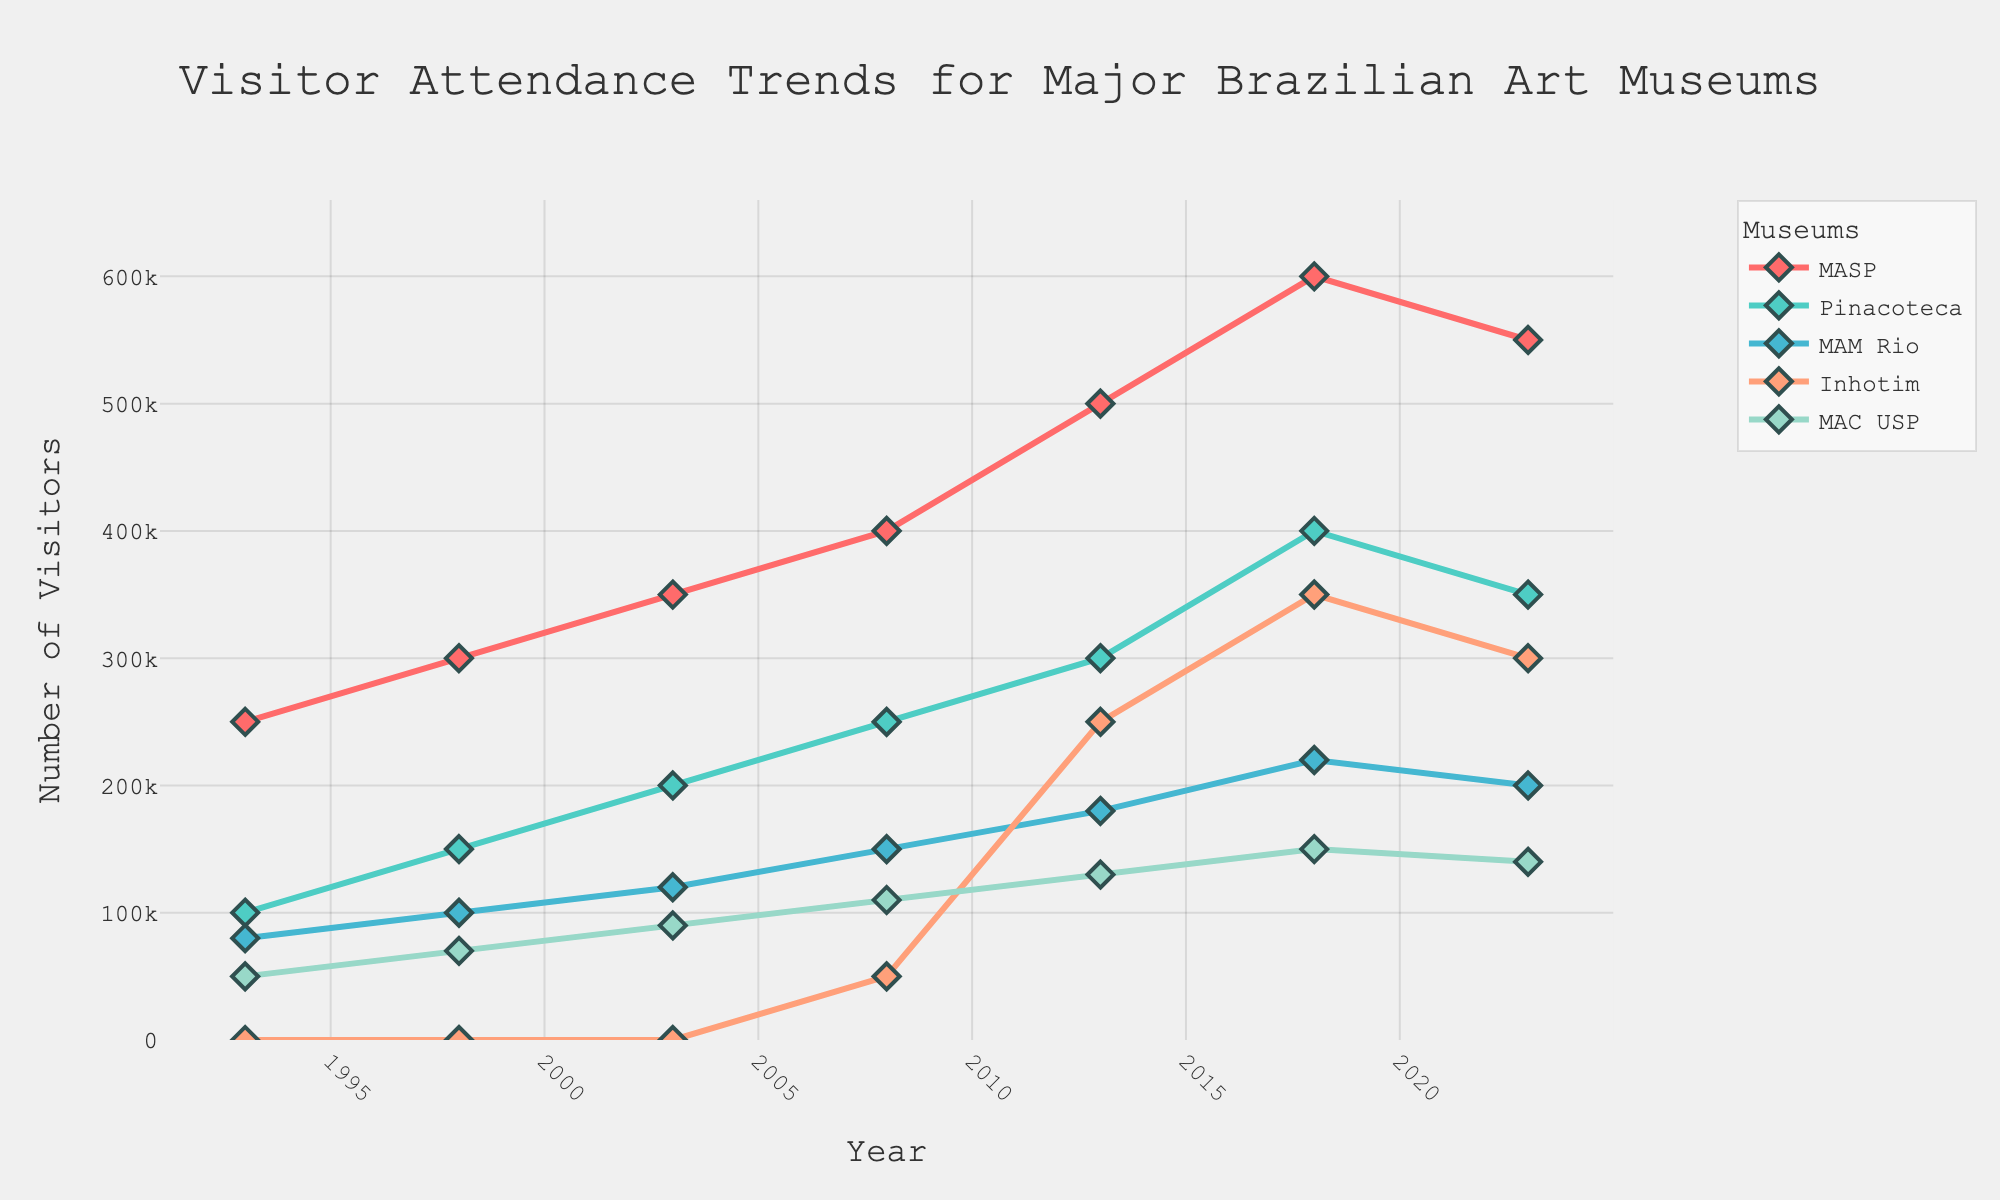How has visitor attendance to MASP (São Paulo Museum of Art) changed over the past 30 years? To determine the change in visitor attendance to MASP, look at the starting value in 1993 and the ending value in 2023. In 1993, it was 250,000, and in 2023, it was 550,000. Subtract the initial value from the final value (550,000 - 250,000) to see the change.
Answer: Increased by 300,000 Which museum had the highest visitor attendance in 2018? To find the highest visitor attendance in 2018, check the values for all museums in that year. The values are MASP: 600,000, Pinacoteca: 400,000, MAM Rio: 220,000, Inhotim: 350,000, and MAC USP: 150,000. MASP has the maximum value.
Answer: MASP What is the average visitor attendance for Pinacoteca over the 30-year period? Calculate the average by summing the attendance values for Pinacoteca across all years and dividing by the number of years. (100,000 + 150,000 + 200,000 + 250,000 + 300,000 + 400,000 + 350,000) totals to 1,750,000. Dividing by 7 years gives an average of 1,750,000 / 7.
Answer: 250,000 How did visitor attendance at Inhotim change from 2018 to 2023? Look at the attendance numbers for Inhotim in 2018 and 2023. The values are 350,000 in 2018 and 300,000 in 2023. Subtract the 2023 value from the 2018 value (300,000 - 350,000) to see the change.
Answer: Decreased by 50,000 Which museum had the most stable visitor attendance over the years? The stability can be assessed by looking at the variation in the visitor attendance numbers. MAC USP has a relatively narrow spread in its values (50,000 to 150,000) compared to others. Thus, it appears most stable.
Answer: MAC USP When did MAM Rio’s visitor attendance see the greatest increase? Calculate the differences in attendance between consecutive years for MAM Rio and identify the largest increase. The increases are (100,000 - 80,000) = 20,000, (120,000 - 100,000) = 20,000, (150,000 - 120,000) = 30,000, (180,000 - 150,000) = 30,000, and (220,000 - 180,000) = 40,000. The greatest increase of 40,000 happened from 2013 to 2018.
Answer: 2013 to 2018 Compare the visitor attendance of MAC USP to MAM Rio in 2003. In 2003, the visitor attendance for MAC USP was 90,000 and for MAM Rio it was 120,000. Comparing these values, MAM Rio had more visitors.
Answer: MAM Rio had more visitors What trend do you observe for Pinacoteca's attendance over time? Observe the plot line for Pinacoteca. The visitor attendance shows a clear upward trend from 100,000 in 1993 to a peak of 400,000 in 2018, despite a slight dip to 150,000 in 2023.
Answer: Mostly increasing How did the opening of Inhotim (started in 2008) affect its attendance over time? Inhotim's visitor attendance data begins in 2008 at 50,000 and rises steadily, reaching a peak of 350,000 in 2018 before slightly dropping to 300,000 in 2023. This shows a general upward trend.
Answer: Increased over time Which museum has the highest total attendance over 30 years? Sum the attendance numbers of each museum for all years. MASP: 2,950,000, Pinacoteca: 1,750,000, MAM Rio: 1,070,000, Inhotim: 1,100,000 (since 2008 only), MAC USP: 790,000. MASP has the highest total attendance.
Answer: MASP 